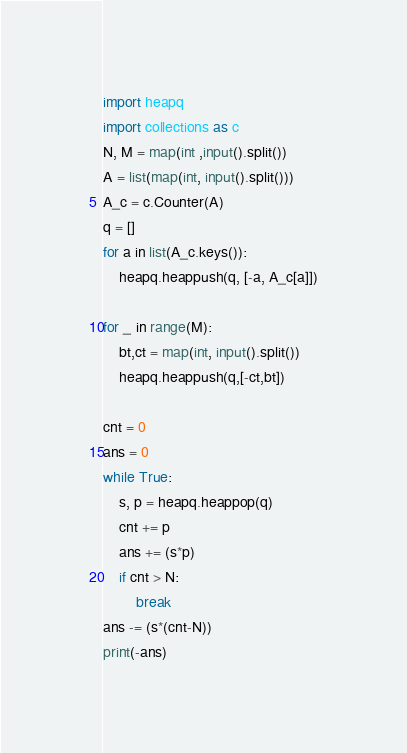Convert code to text. <code><loc_0><loc_0><loc_500><loc_500><_Python_>import heapq
import collections as c
N, M = map(int ,input().split())
A = list(map(int, input().split()))
A_c = c.Counter(A)
q = []
for a in list(A_c.keys()):
	heapq.heappush(q, [-a, A_c[a]])

for _ in range(M):
	bt,ct = map(int, input().split())
	heapq.heappush(q,[-ct,bt])

cnt = 0
ans = 0
while True:
	s, p = heapq.heappop(q)
	cnt += p
	ans += (s*p)
	if cnt > N:
		break
ans -= (s*(cnt-N))
print(-ans)

</code> 